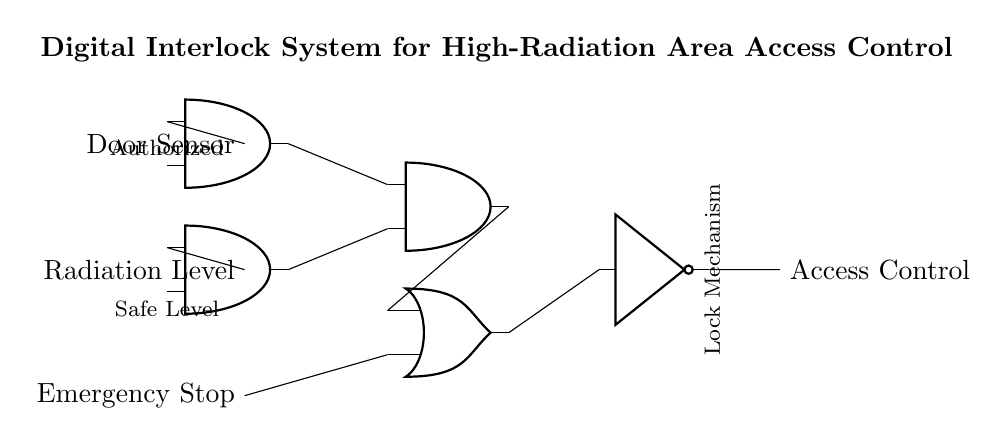What are the inputs to the circuit? The inputs to the circuit are the door sensor, radiation level, and emergency stop, which are located on the left side of the diagram.
Answer: Door sensor, radiation level, emergency stop What logic gates are used in this circuit? The circuit utilizes AND gates, an OR gate, and a NOT gate as indicated by their respective symbols in the diagram.
Answer: AND gates, OR gate, NOT gate How many AND gates are depicted in the circuit? The diagram shows three AND gates as represented by their symbols, which perform logical conjunction.
Answer: Three What condition must be met for the access control mechanism to be active? The access control mechanism activates when both the door sensor indicates authorized and the radiation level indicates safe level, as connected through the AND gates.
Answer: Authorized and safe level What is the function of the NOT gate in this circuit? The NOT gate inverts the output from the OR gate, thus controlling the locking mechanism in response to the combined input conditions from the AND gates. When the OR gate output is high, the NOT gate outputs low, preventing access.
Answer: Invert access condition If the emergency stop is activated, what happens to the access control output? Activation of the emergency stop directly inputs into the OR gate, which would lead to a high output from the OR gate if combined with the conditions that allow access, thus allowing the NOT gate to function accordingly.
Answer: Depends on other inputs What is the purpose of the digital interlock system in high-radiation areas? The digital interlock system aims to prevent unauthorized access to areas with high radiation by requiring specific conditions to be met before granting access.
Answer: Prevent unauthorized access 